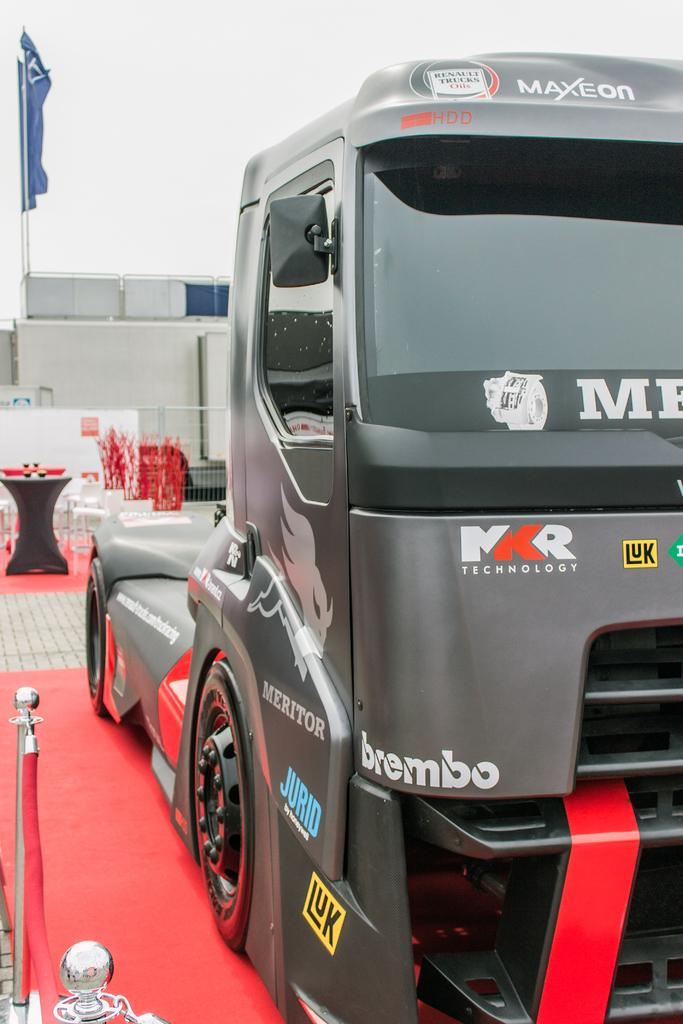What is the main subject of the image? There is a truck in the image. Can you describe the setting of the image? The truck is on a red carpet. What type of sign can be seen hanging from the truck in the image? There is no sign hanging from the truck in the image. How many dolls are sitting on the red carpet next to the truck? There are no dolls present in the image. 